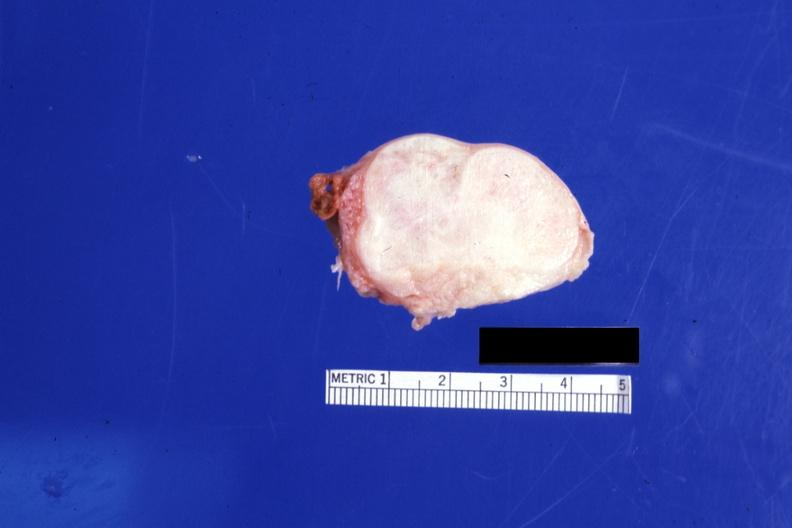what is present?
Answer the question using a single word or phrase. Fibroma 